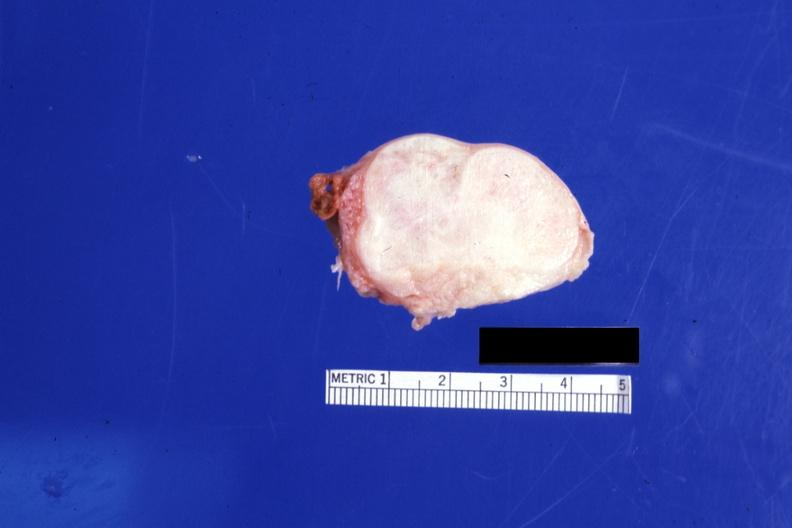what is present?
Answer the question using a single word or phrase. Fibroma 